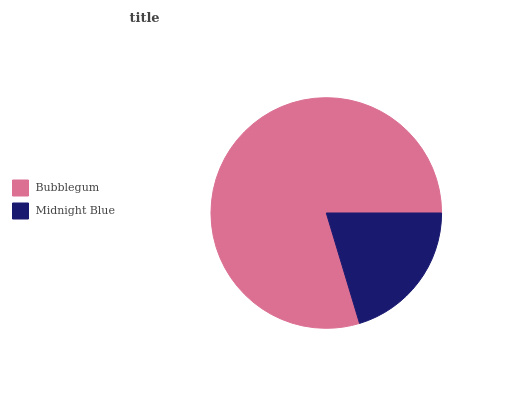Is Midnight Blue the minimum?
Answer yes or no. Yes. Is Bubblegum the maximum?
Answer yes or no. Yes. Is Midnight Blue the maximum?
Answer yes or no. No. Is Bubblegum greater than Midnight Blue?
Answer yes or no. Yes. Is Midnight Blue less than Bubblegum?
Answer yes or no. Yes. Is Midnight Blue greater than Bubblegum?
Answer yes or no. No. Is Bubblegum less than Midnight Blue?
Answer yes or no. No. Is Bubblegum the high median?
Answer yes or no. Yes. Is Midnight Blue the low median?
Answer yes or no. Yes. Is Midnight Blue the high median?
Answer yes or no. No. Is Bubblegum the low median?
Answer yes or no. No. 